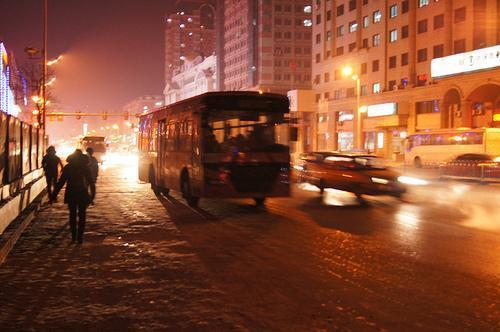How many people can be seen?
Give a very brief answer. 4. How many buildings are seen?
Give a very brief answer. 5. How many buses can be seen?
Give a very brief answer. 3. 